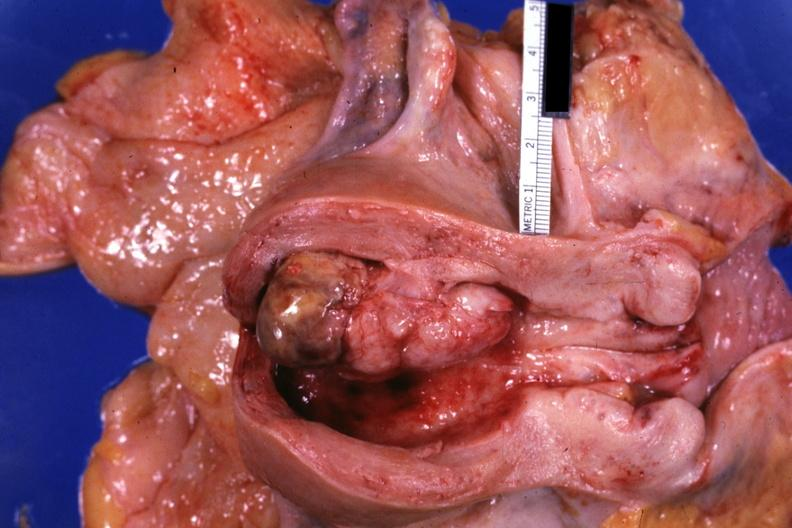s breast present?
Answer the question using a single word or phrase. No 